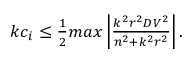<formula> <loc_0><loc_0><loc_500><loc_500>\begin{array} { r } { k c _ { i } \leq \frac { 1 } { 2 } \max \left | \frac { k ^ { 2 } r ^ { 2 } D V ^ { 2 } } { n ^ { 2 } + k ^ { 2 } r ^ { 2 } } \right | . } \end{array}</formula> 